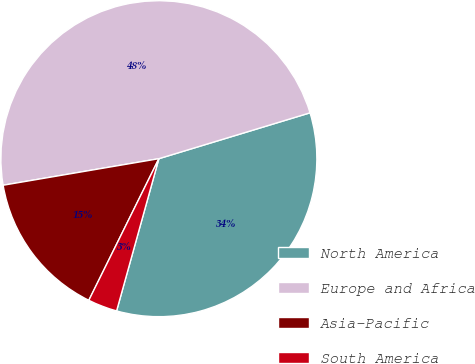<chart> <loc_0><loc_0><loc_500><loc_500><pie_chart><fcel>North America<fcel>Europe and Africa<fcel>Asia-Pacific<fcel>South America<nl><fcel>34.0%<fcel>48.0%<fcel>15.0%<fcel>3.0%<nl></chart> 